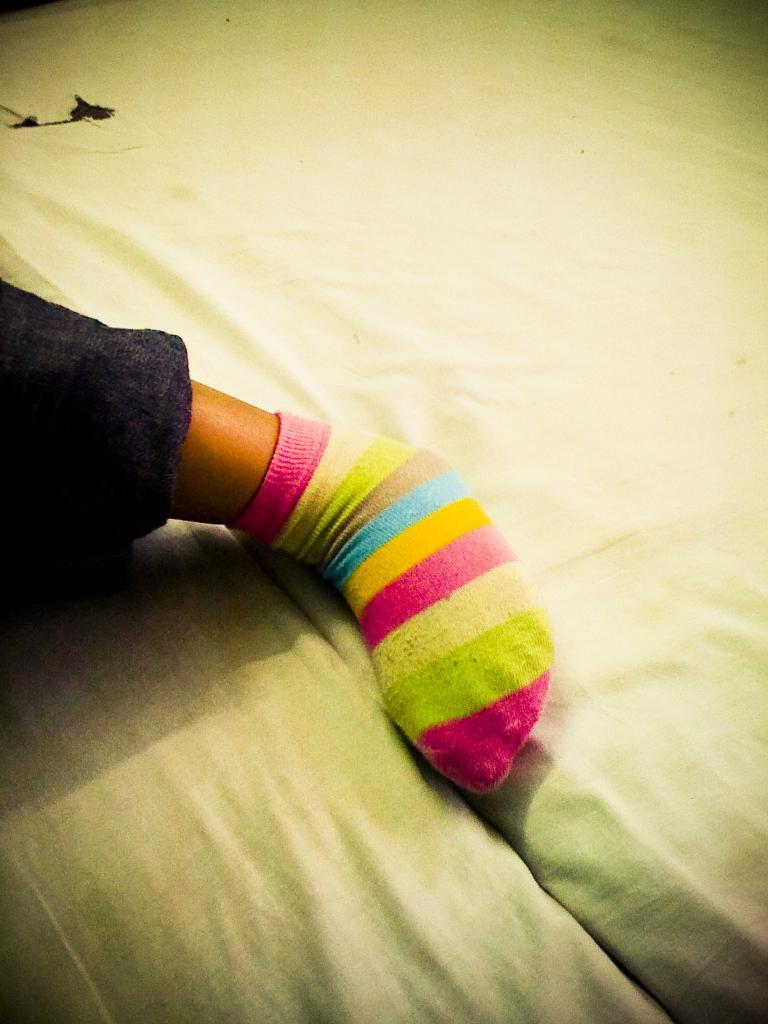In one or two sentences, can you explain what this image depicts? In this image I can see a person leg and I can see a stocks and I can see white color bed sheet in the middle. 